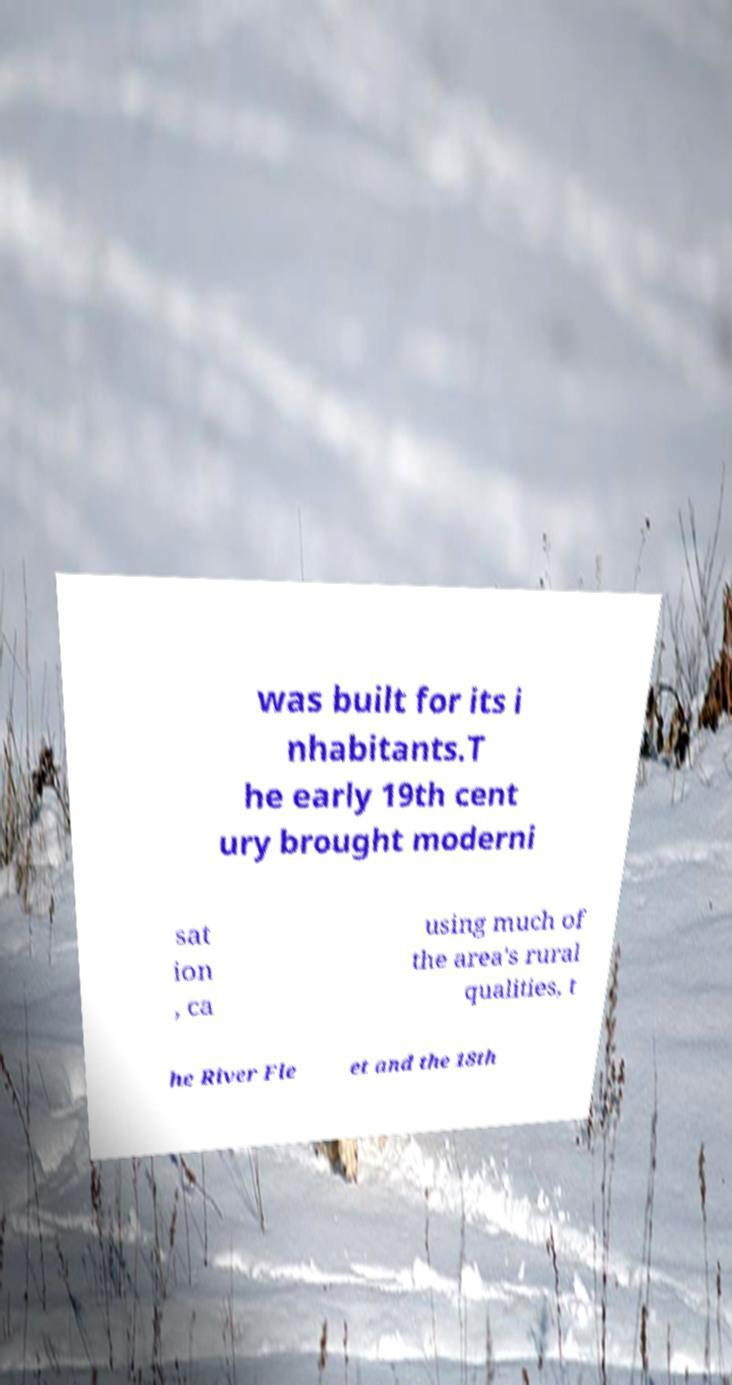Please read and relay the text visible in this image. What does it say? was built for its i nhabitants.T he early 19th cent ury brought moderni sat ion , ca using much of the area's rural qualities, t he River Fle et and the 18th 